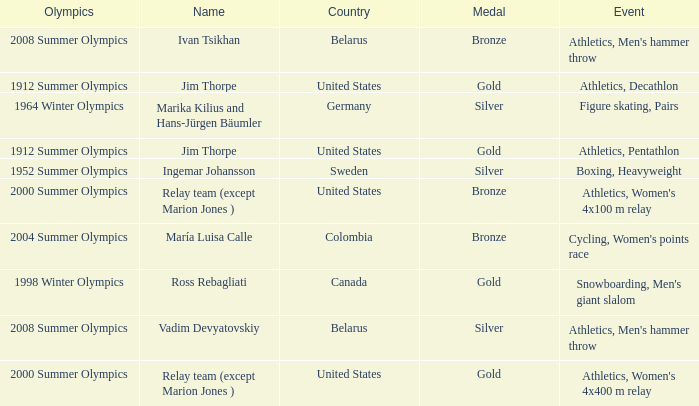What country has a silver medal in the boxing, heavyweight event? Sweden. 